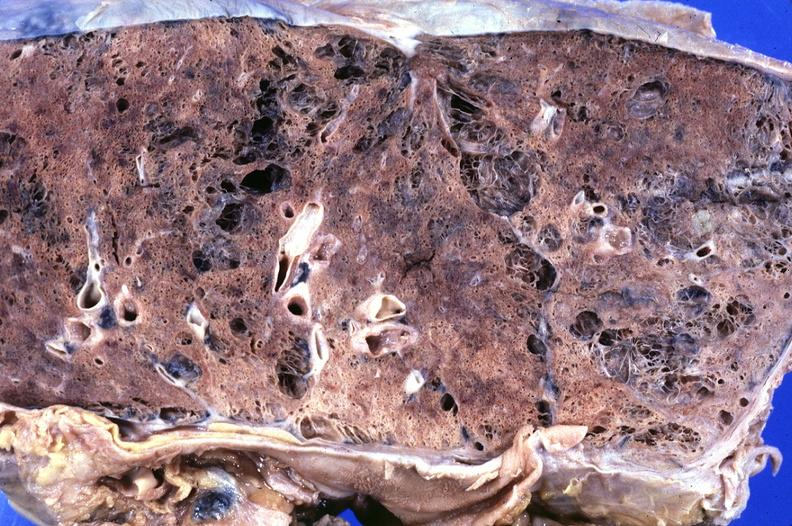does this image show lung, emphysema?
Answer the question using a single word or phrase. Yes 